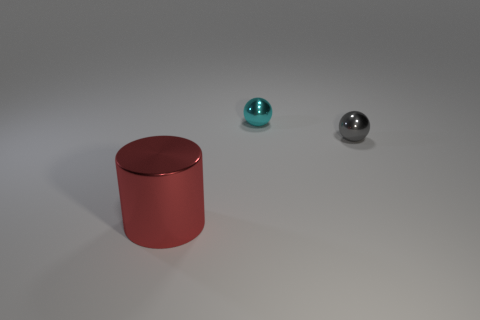Add 1 large green metal objects. How many objects exist? 4 Subtract 1 red cylinders. How many objects are left? 2 Subtract all spheres. How many objects are left? 1 Subtract all brown cylinders. Subtract all green cubes. How many cylinders are left? 1 Subtract all small gray metal spheres. Subtract all cyan metal balls. How many objects are left? 1 Add 2 metal objects. How many metal objects are left? 5 Add 1 large cylinders. How many large cylinders exist? 2 